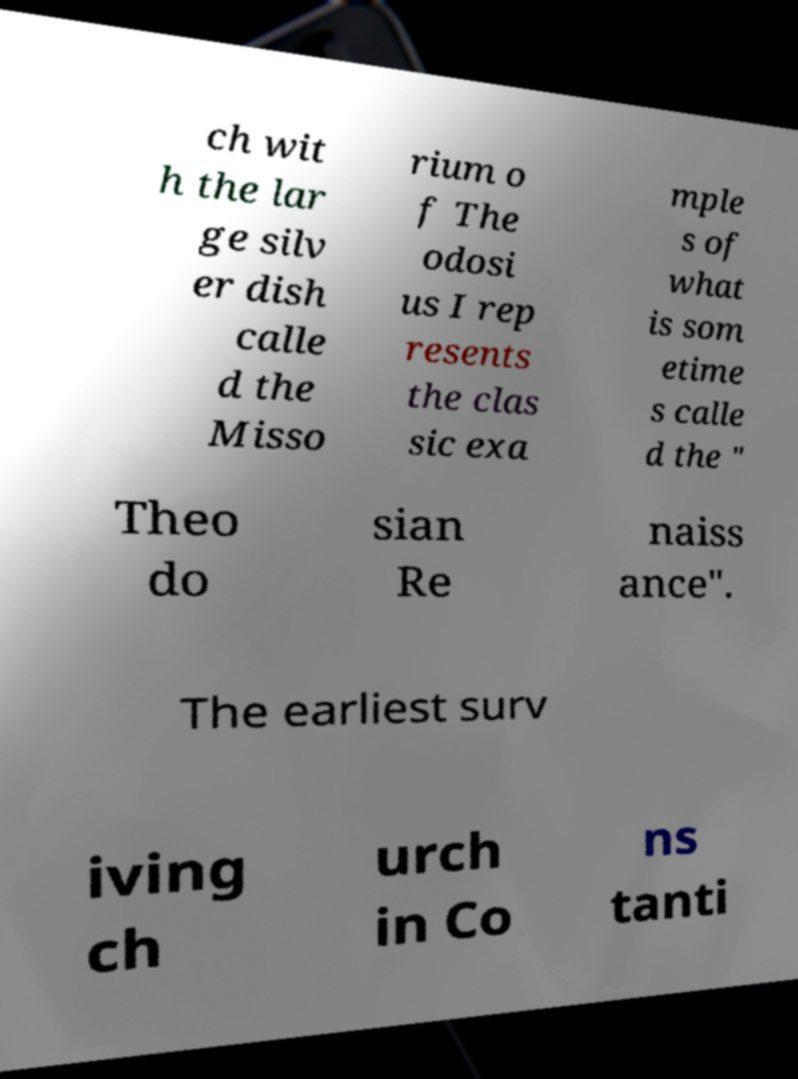For documentation purposes, I need the text within this image transcribed. Could you provide that? ch wit h the lar ge silv er dish calle d the Misso rium o f The odosi us I rep resents the clas sic exa mple s of what is som etime s calle d the " Theo do sian Re naiss ance". The earliest surv iving ch urch in Co ns tanti 